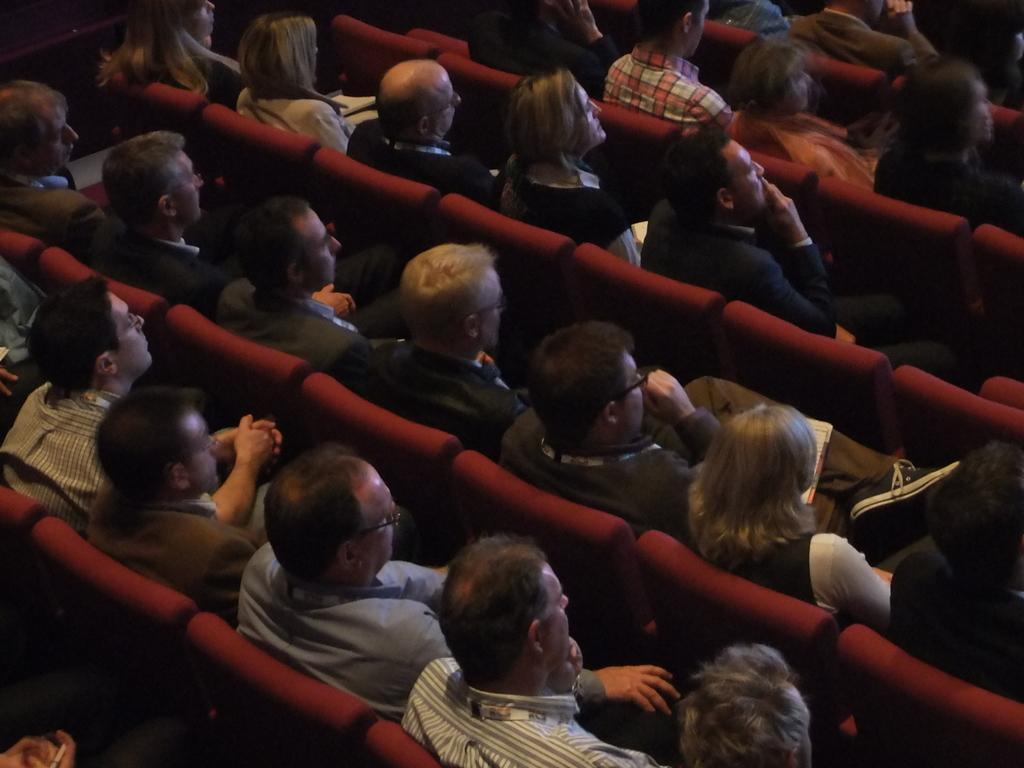Describe this image in one or two sentences. In this picture we can see some people are sitting on chairs and looking at something. 